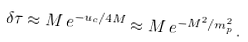<formula> <loc_0><loc_0><loc_500><loc_500>\delta \tau \approx M \, e ^ { - { u _ { c } } / { 4 M } } \approx M \, e ^ { - { M ^ { 2 } } / { m _ { p } ^ { 2 } } } \, .</formula> 